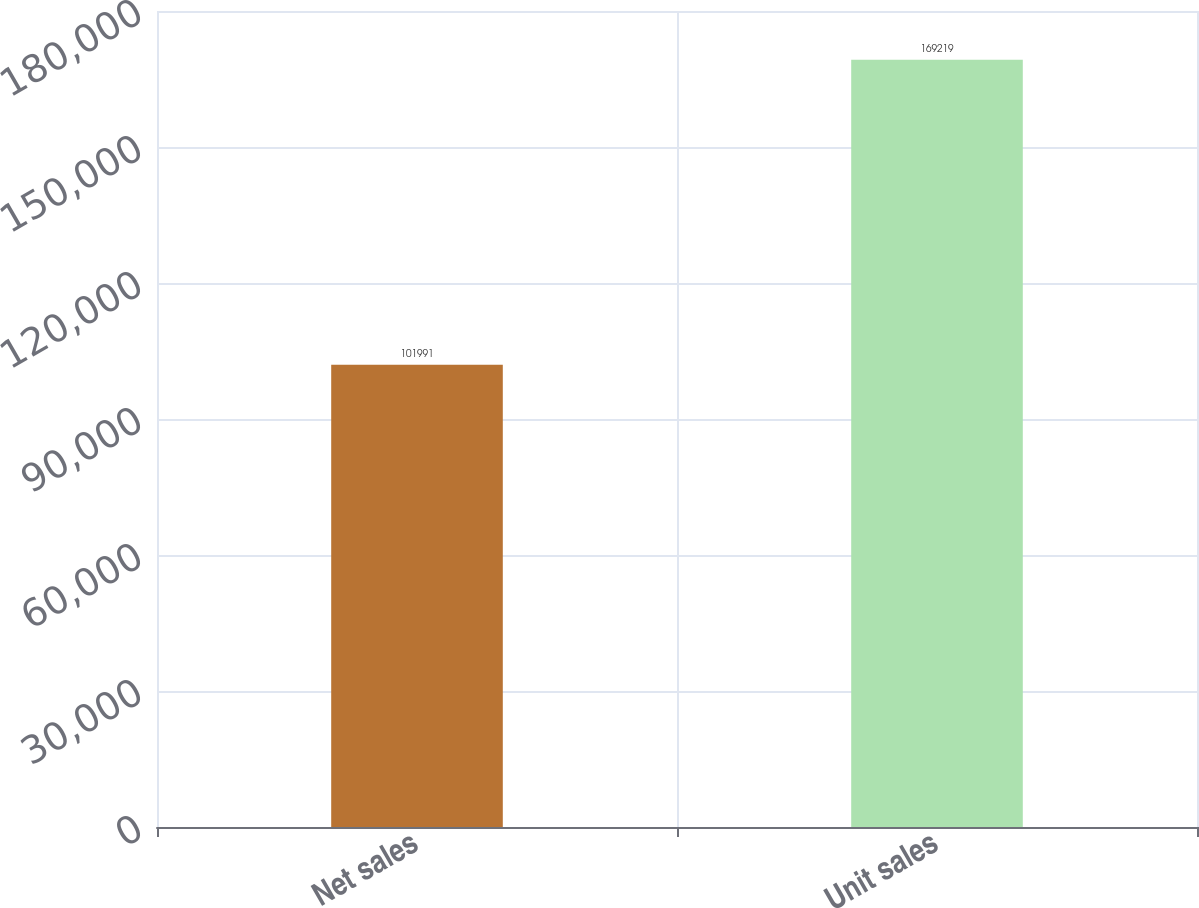<chart> <loc_0><loc_0><loc_500><loc_500><bar_chart><fcel>Net sales<fcel>Unit sales<nl><fcel>101991<fcel>169219<nl></chart> 